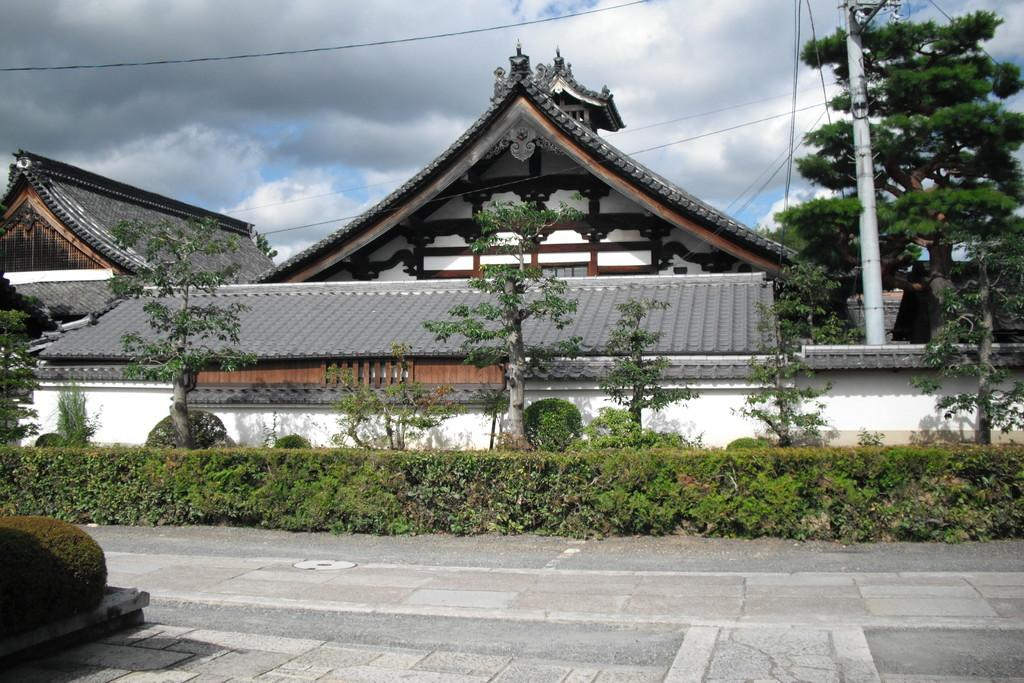What type of structures can be seen in the image? There are houses in the image. What other natural elements are present in the image? There are plants, trees, and the sky visible in the image. Can you describe any man-made objects in the image? There is a pole and wires in the image. What is the condition of the sky in the image? The sky appears cloudy in the image. What type of barrier can be seen in the image? There is a wall in the image. What is the price of the chain hanging from the pole in the image? There is no chain hanging from the pole in the image. Can you see any mountains in the background of the image? There are no mountains visible in the image. 